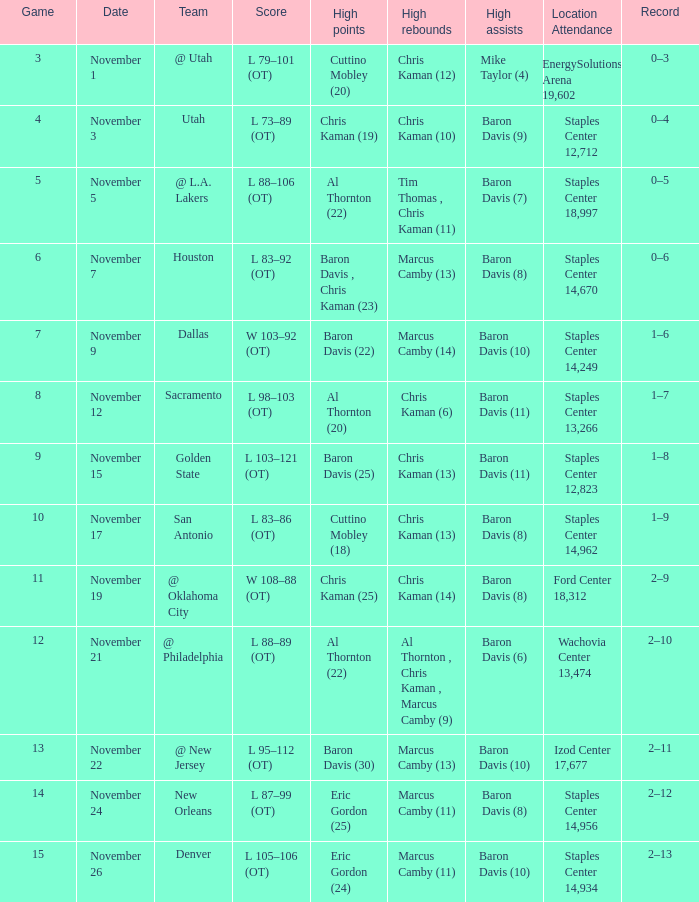Identify the important milestones for november 24 throughout history. Eric Gordon (25). Would you mind parsing the complete table? {'header': ['Game', 'Date', 'Team', 'Score', 'High points', 'High rebounds', 'High assists', 'Location Attendance', 'Record'], 'rows': [['3', 'November 1', '@ Utah', 'L 79–101 (OT)', 'Cuttino Mobley (20)', 'Chris Kaman (12)', 'Mike Taylor (4)', 'EnergySolutions Arena 19,602', '0–3'], ['4', 'November 3', 'Utah', 'L 73–89 (OT)', 'Chris Kaman (19)', 'Chris Kaman (10)', 'Baron Davis (9)', 'Staples Center 12,712', '0–4'], ['5', 'November 5', '@ L.A. Lakers', 'L 88–106 (OT)', 'Al Thornton (22)', 'Tim Thomas , Chris Kaman (11)', 'Baron Davis (7)', 'Staples Center 18,997', '0–5'], ['6', 'November 7', 'Houston', 'L 83–92 (OT)', 'Baron Davis , Chris Kaman (23)', 'Marcus Camby (13)', 'Baron Davis (8)', 'Staples Center 14,670', '0–6'], ['7', 'November 9', 'Dallas', 'W 103–92 (OT)', 'Baron Davis (22)', 'Marcus Camby (14)', 'Baron Davis (10)', 'Staples Center 14,249', '1–6'], ['8', 'November 12', 'Sacramento', 'L 98–103 (OT)', 'Al Thornton (20)', 'Chris Kaman (6)', 'Baron Davis (11)', 'Staples Center 13,266', '1–7'], ['9', 'November 15', 'Golden State', 'L 103–121 (OT)', 'Baron Davis (25)', 'Chris Kaman (13)', 'Baron Davis (11)', 'Staples Center 12,823', '1–8'], ['10', 'November 17', 'San Antonio', 'L 83–86 (OT)', 'Cuttino Mobley (18)', 'Chris Kaman (13)', 'Baron Davis (8)', 'Staples Center 14,962', '1–9'], ['11', 'November 19', '@ Oklahoma City', 'W 108–88 (OT)', 'Chris Kaman (25)', 'Chris Kaman (14)', 'Baron Davis (8)', 'Ford Center 18,312', '2–9'], ['12', 'November 21', '@ Philadelphia', 'L 88–89 (OT)', 'Al Thornton (22)', 'Al Thornton , Chris Kaman , Marcus Camby (9)', 'Baron Davis (6)', 'Wachovia Center 13,474', '2–10'], ['13', 'November 22', '@ New Jersey', 'L 95–112 (OT)', 'Baron Davis (30)', 'Marcus Camby (13)', 'Baron Davis (10)', 'Izod Center 17,677', '2–11'], ['14', 'November 24', 'New Orleans', 'L 87–99 (OT)', 'Eric Gordon (25)', 'Marcus Camby (11)', 'Baron Davis (8)', 'Staples Center 14,956', '2–12'], ['15', 'November 26', 'Denver', 'L 105–106 (OT)', 'Eric Gordon (24)', 'Marcus Camby (11)', 'Baron Davis (10)', 'Staples Center 14,934', '2–13']]} 